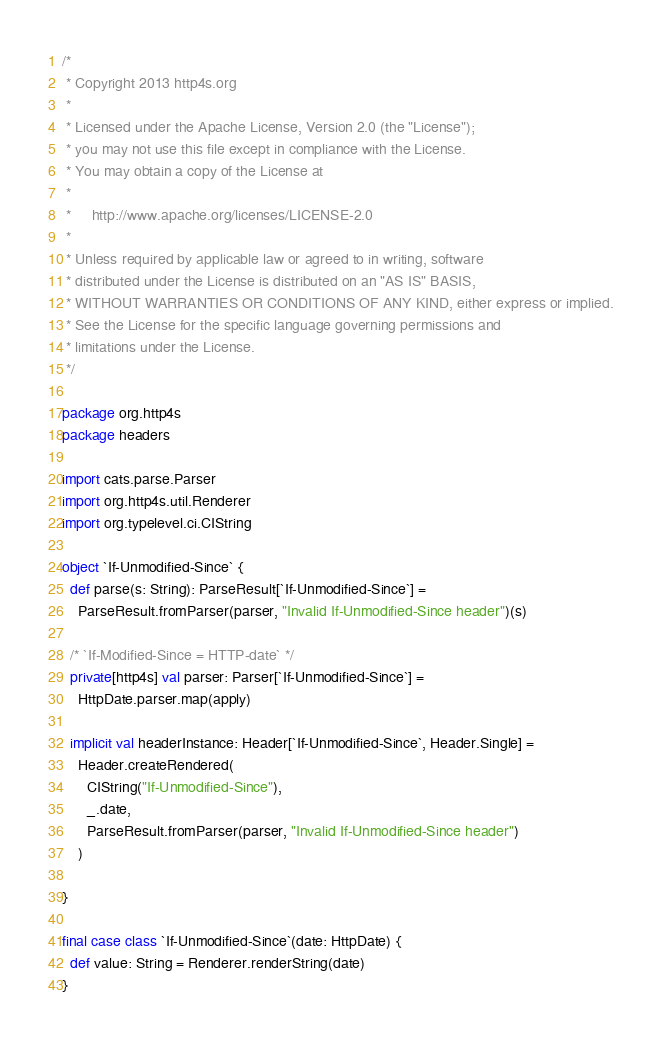Convert code to text. <code><loc_0><loc_0><loc_500><loc_500><_Scala_>/*
 * Copyright 2013 http4s.org
 *
 * Licensed under the Apache License, Version 2.0 (the "License");
 * you may not use this file except in compliance with the License.
 * You may obtain a copy of the License at
 *
 *     http://www.apache.org/licenses/LICENSE-2.0
 *
 * Unless required by applicable law or agreed to in writing, software
 * distributed under the License is distributed on an "AS IS" BASIS,
 * WITHOUT WARRANTIES OR CONDITIONS OF ANY KIND, either express or implied.
 * See the License for the specific language governing permissions and
 * limitations under the License.
 */

package org.http4s
package headers

import cats.parse.Parser
import org.http4s.util.Renderer
import org.typelevel.ci.CIString

object `If-Unmodified-Since` {
  def parse(s: String): ParseResult[`If-Unmodified-Since`] =
    ParseResult.fromParser(parser, "Invalid If-Unmodified-Since header")(s)

  /* `If-Modified-Since = HTTP-date` */
  private[http4s] val parser: Parser[`If-Unmodified-Since`] =
    HttpDate.parser.map(apply)

  implicit val headerInstance: Header[`If-Unmodified-Since`, Header.Single] =
    Header.createRendered(
      CIString("If-Unmodified-Since"),
      _.date,
      ParseResult.fromParser(parser, "Invalid If-Unmodified-Since header")
    )

}

final case class `If-Unmodified-Since`(date: HttpDate) {
  def value: String = Renderer.renderString(date)
}
</code> 